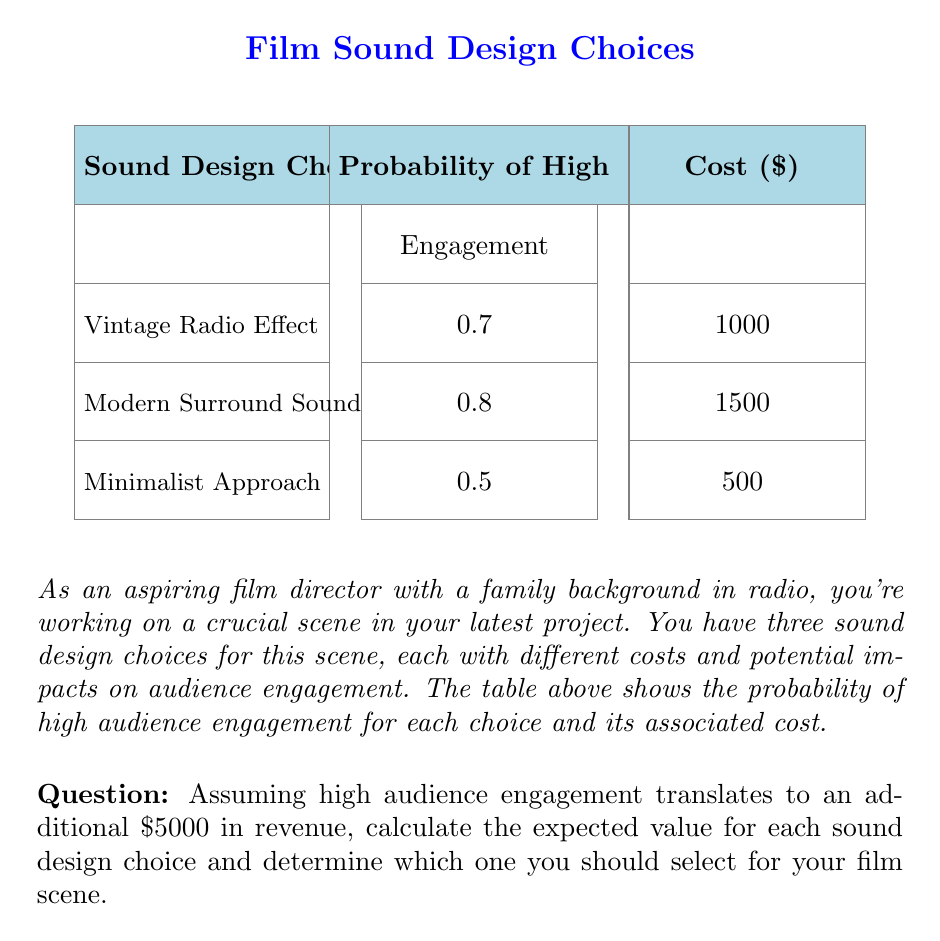Can you answer this question? To solve this problem, we need to calculate the expected value for each sound design choice and compare them. The expected value is the sum of each possible outcome multiplied by its probability.

For each choice, we have two possible outcomes:
1. High engagement (with the given probability)
2. Low engagement (1 - probability of high engagement)

Let's calculate the expected value for each choice:

1. Vintage Radio Effect:
   Probability of high engagement = 0.7
   Probability of low engagement = 1 - 0.7 = 0.3
   
   Expected Value = (0.7 × ($5000 - $1000)) + (0.3 × (-$1000))
                  = $2800 - $300
                  = $2500

2. Modern Surround Sound:
   Probability of high engagement = 0.8
   Probability of low engagement = 1 - 0.8 = 0.2
   
   Expected Value = (0.8 × ($5000 - $1500)) + (0.2 × (-$1500))
                  = $2800 - $300
                  = $2500

3. Minimalist Approach:
   Probability of high engagement = 0.5
   Probability of low engagement = 1 - 0.5 = 0.5
   
   Expected Value = (0.5 × ($5000 - $500)) + (0.5 × (-$500))
                  = $2250 - $250
                  = $2000

The expected values for the Vintage Radio Effect and Modern Surround Sound are both $2500, while the Minimalist Approach has an expected value of $2000.

Therefore, you should choose either the Vintage Radio Effect or the Modern Surround Sound, as they both have the highest expected value of $2500.
Answer: Choose Vintage Radio Effect or Modern Surround Sound (Expected Value: $2500) 